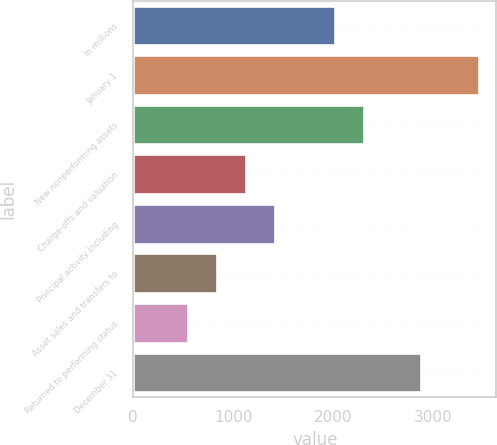Convert chart. <chart><loc_0><loc_0><loc_500><loc_500><bar_chart><fcel>In millions<fcel>January 1<fcel>New nonperforming assets<fcel>Charge-offs and valuation<fcel>Principal activity including<fcel>Asset sales and transfers to<fcel>Returned to performing status<fcel>December 31<nl><fcel>2014<fcel>3457<fcel>2304.9<fcel>1129.8<fcel>1420.7<fcel>838.9<fcel>548<fcel>2880<nl></chart> 